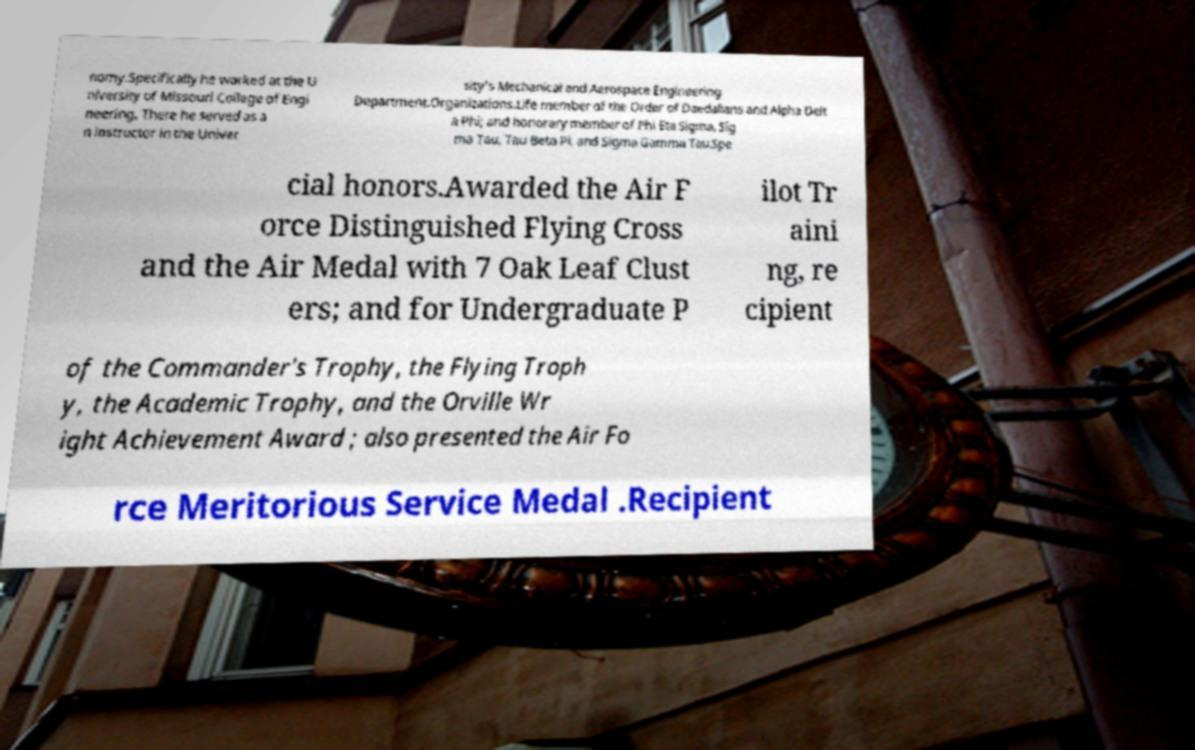For documentation purposes, I need the text within this image transcribed. Could you provide that? nomy.Specifically he worked at the U niversity of Missouri College of Engi neering. There he served as a n instructor in the Univer sity's Mechanical and Aerospace Engineering Department.Organizations.Life member of the Order of Daedalians and Alpha Delt a Phi; and honorary member of Phi Eta Sigma, Sig ma Tau, Tau Beta Pi, and Sigma Gamma Tau.Spe cial honors.Awarded the Air F orce Distinguished Flying Cross and the Air Medal with 7 Oak Leaf Clust ers; and for Undergraduate P ilot Tr aini ng, re cipient of the Commander's Trophy, the Flying Troph y, the Academic Trophy, and the Orville Wr ight Achievement Award ; also presented the Air Fo rce Meritorious Service Medal .Recipient 